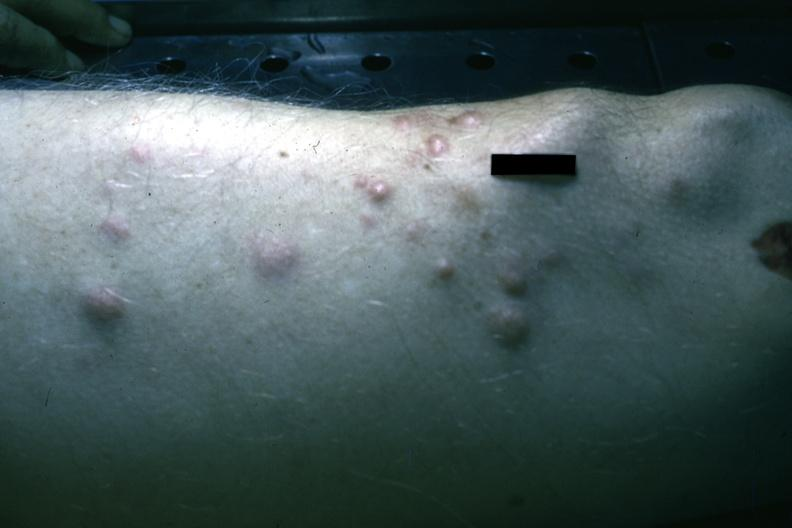where is this?
Answer the question using a single word or phrase. Skin 